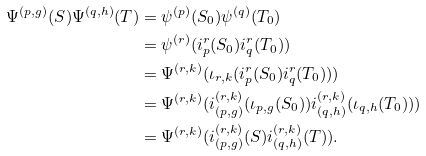<formula> <loc_0><loc_0><loc_500><loc_500>\Psi ^ { ( p , g ) } ( S ) \Psi ^ { ( q , h ) } ( T ) & = \psi ^ { ( p ) } ( S _ { 0 } ) \psi ^ { ( q ) } ( T _ { 0 } ) \\ & = \psi ^ { ( r ) } ( i _ { p } ^ { r } ( S _ { 0 } ) i _ { q } ^ { r } ( T _ { 0 } ) ) \\ & = \Psi ^ { ( r , k ) } ( \iota _ { r , k } ( i _ { p } ^ { r } ( S _ { 0 } ) i _ { q } ^ { r } ( T _ { 0 } ) ) ) \\ & = \Psi ^ { ( r , k ) } ( i _ { ( p , g ) } ^ { ( r , k ) } ( \iota _ { p , g } ( S _ { 0 } ) ) i _ { ( q , h ) } ^ { ( r , k ) } ( \iota _ { q , h } ( T _ { 0 } ) ) ) \\ & = \Psi ^ { ( r , k ) } ( i _ { ( p , g ) } ^ { ( r , k ) } ( S ) i _ { ( q , h ) } ^ { ( r , k ) } ( T ) ) .</formula> 